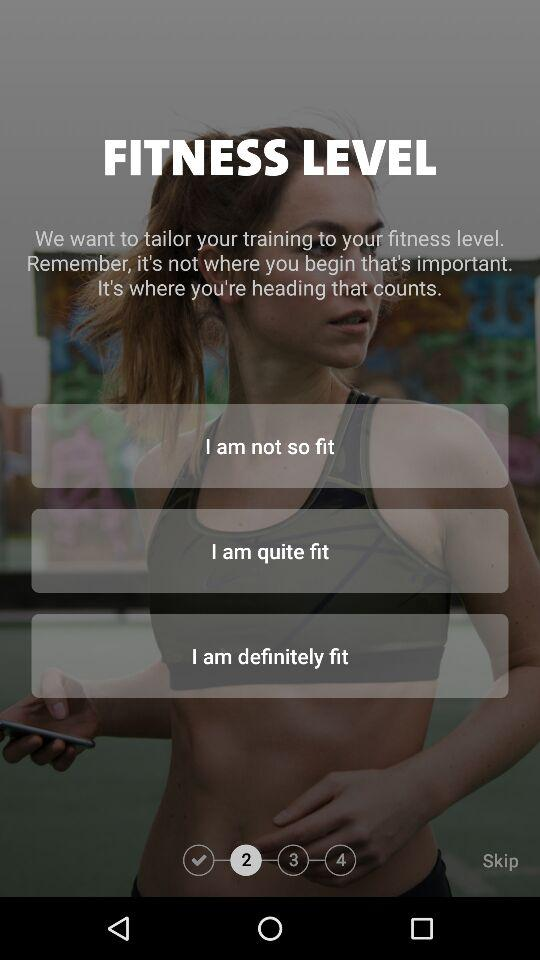Which step are we currently at? You are currently at the second step. 